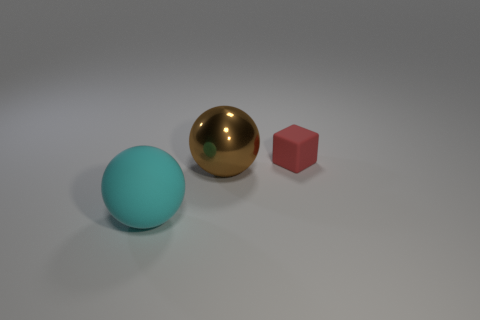Is the color of the ball that is right of the cyan rubber thing the same as the big matte sphere?
Your answer should be compact. No. How many objects are in front of the big brown metal object?
Give a very brief answer. 1. Is the red block made of the same material as the big sphere left of the shiny ball?
Offer a very short reply. Yes. There is a thing that is made of the same material as the cyan sphere; what is its size?
Offer a terse response. Small. Are there more tiny red cubes that are on the left side of the large rubber sphere than big cyan matte balls that are on the right side of the large brown shiny sphere?
Your answer should be compact. No. Are there any cyan objects that have the same shape as the brown metal object?
Offer a terse response. Yes. Does the thing to the right of the brown shiny object have the same size as the matte ball?
Your response must be concise. No. Is there a brown object?
Your response must be concise. Yes. How many objects are balls in front of the large brown sphere or yellow rubber things?
Provide a short and direct response. 1. Do the large matte sphere and the rubber thing that is behind the shiny object have the same color?
Provide a succinct answer. No. 